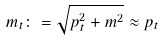Convert formula to latex. <formula><loc_0><loc_0><loc_500><loc_500>m _ { t } \colon = \sqrt { p _ { t } ^ { 2 } + m ^ { 2 } } \approx p _ { t }</formula> 